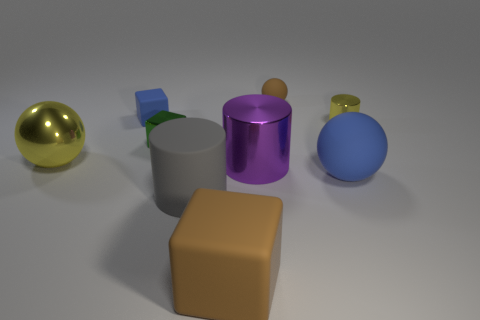Subtract all balls. How many objects are left? 6 Add 3 tiny green shiny objects. How many tiny green shiny objects are left? 4 Add 5 purple metal cylinders. How many purple metal cylinders exist? 6 Subtract 0 purple balls. How many objects are left? 9 Subtract all big brown objects. Subtract all blocks. How many objects are left? 5 